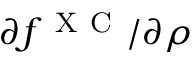Convert formula to latex. <formula><loc_0><loc_0><loc_500><loc_500>{ \partial f ^ { X C } } / { \partial \rho }</formula> 